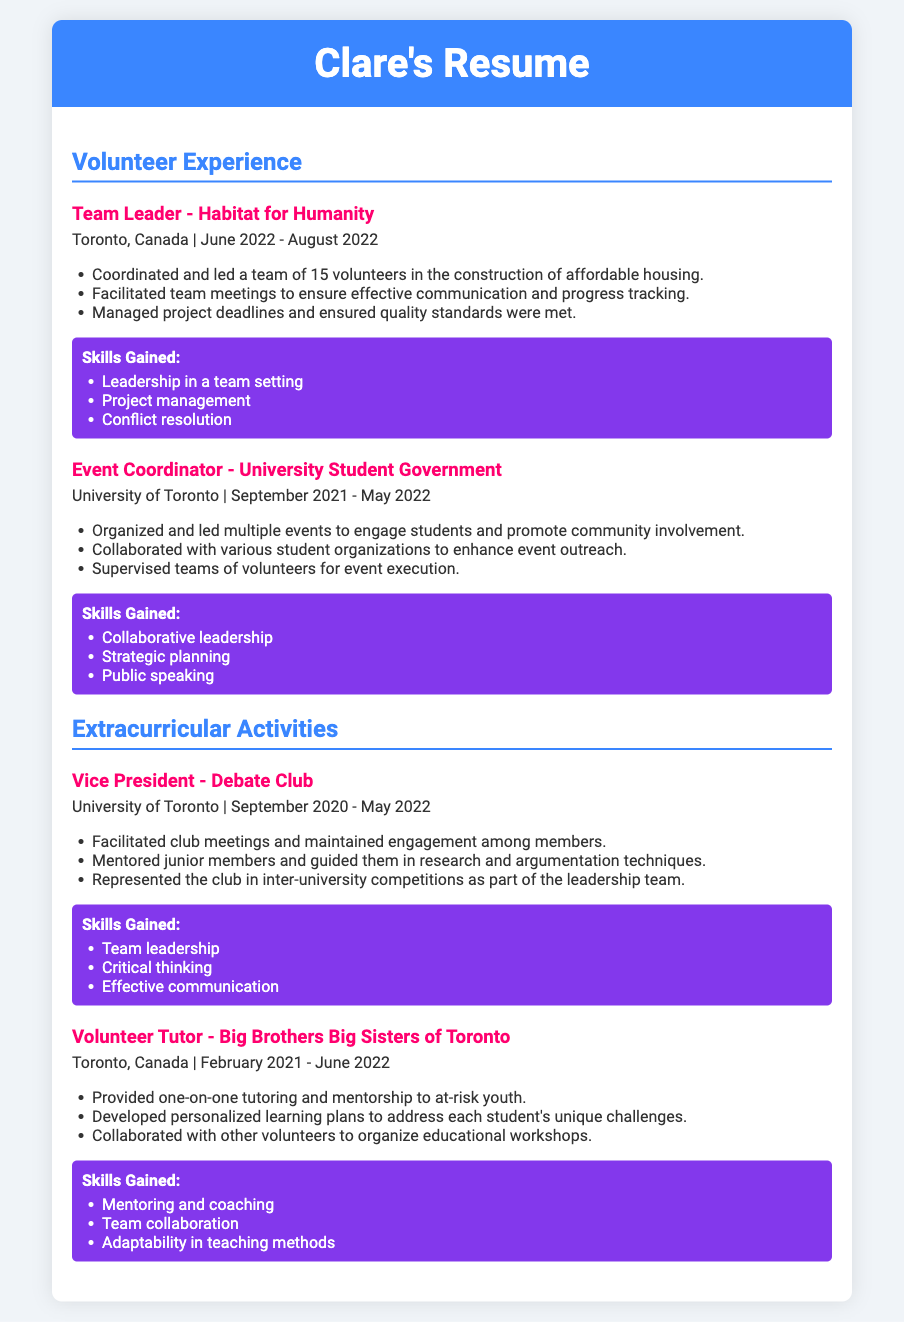What position did Clare hold at Habitat for Humanity? The position Clare held at Habitat for Humanity is mentioned as Team Leader, which reflects her leadership role in the organization.
Answer: Team Leader In which city did Clare volunteer for Big Brothers Big Sisters? The city where Clare volunteered for Big Brothers Big Sisters of Toronto is specified as Toronto, Canada.
Answer: Toronto, Canada What did Clare coordinate as an Event Coordinator? Clare coordinated multiple events aimed at engaging students, showcasing her ability to organize community activities.
Answer: Events During which period did Clare serve as Vice President of the Debate Club? The period of Clare's service as Vice President of the Debate Club is indicated as September 2020 to May 2022.
Answer: September 2020 - May 2022 How many volunteers did Clare lead at Habitat for Humanity? The number of volunteers Clare coordinated in her leadership role at Habitat for Humanity is stated as 15.
Answer: 15 Which skill did Clare develop through her role with Big Brothers Big Sisters? Clare developed mentoring and coaching skills through her experience providing one-on-one tutoring and mentorship.
Answer: Mentoring and coaching Describe a responsibility of Clare as a Volunteer Tutor. A responsibility of Clare as a Volunteer Tutor was to provide one-on-one tutoring, indicating her direct involvement with students.
Answer: One-on-one tutoring What aspect of leadership did Clare demonstrate in the University Student Government? Clare demonstrated collaborative leadership while organizing and leading multiple events, reflecting her teamwork abilities.
Answer: Collaborative leadership Which skill involved public speaking that Clare gained as an Event Coordinator? The skill that involved public speaking gained by Clare in her role as Event Coordinator is explicitly mentioned.
Answer: Public speaking 